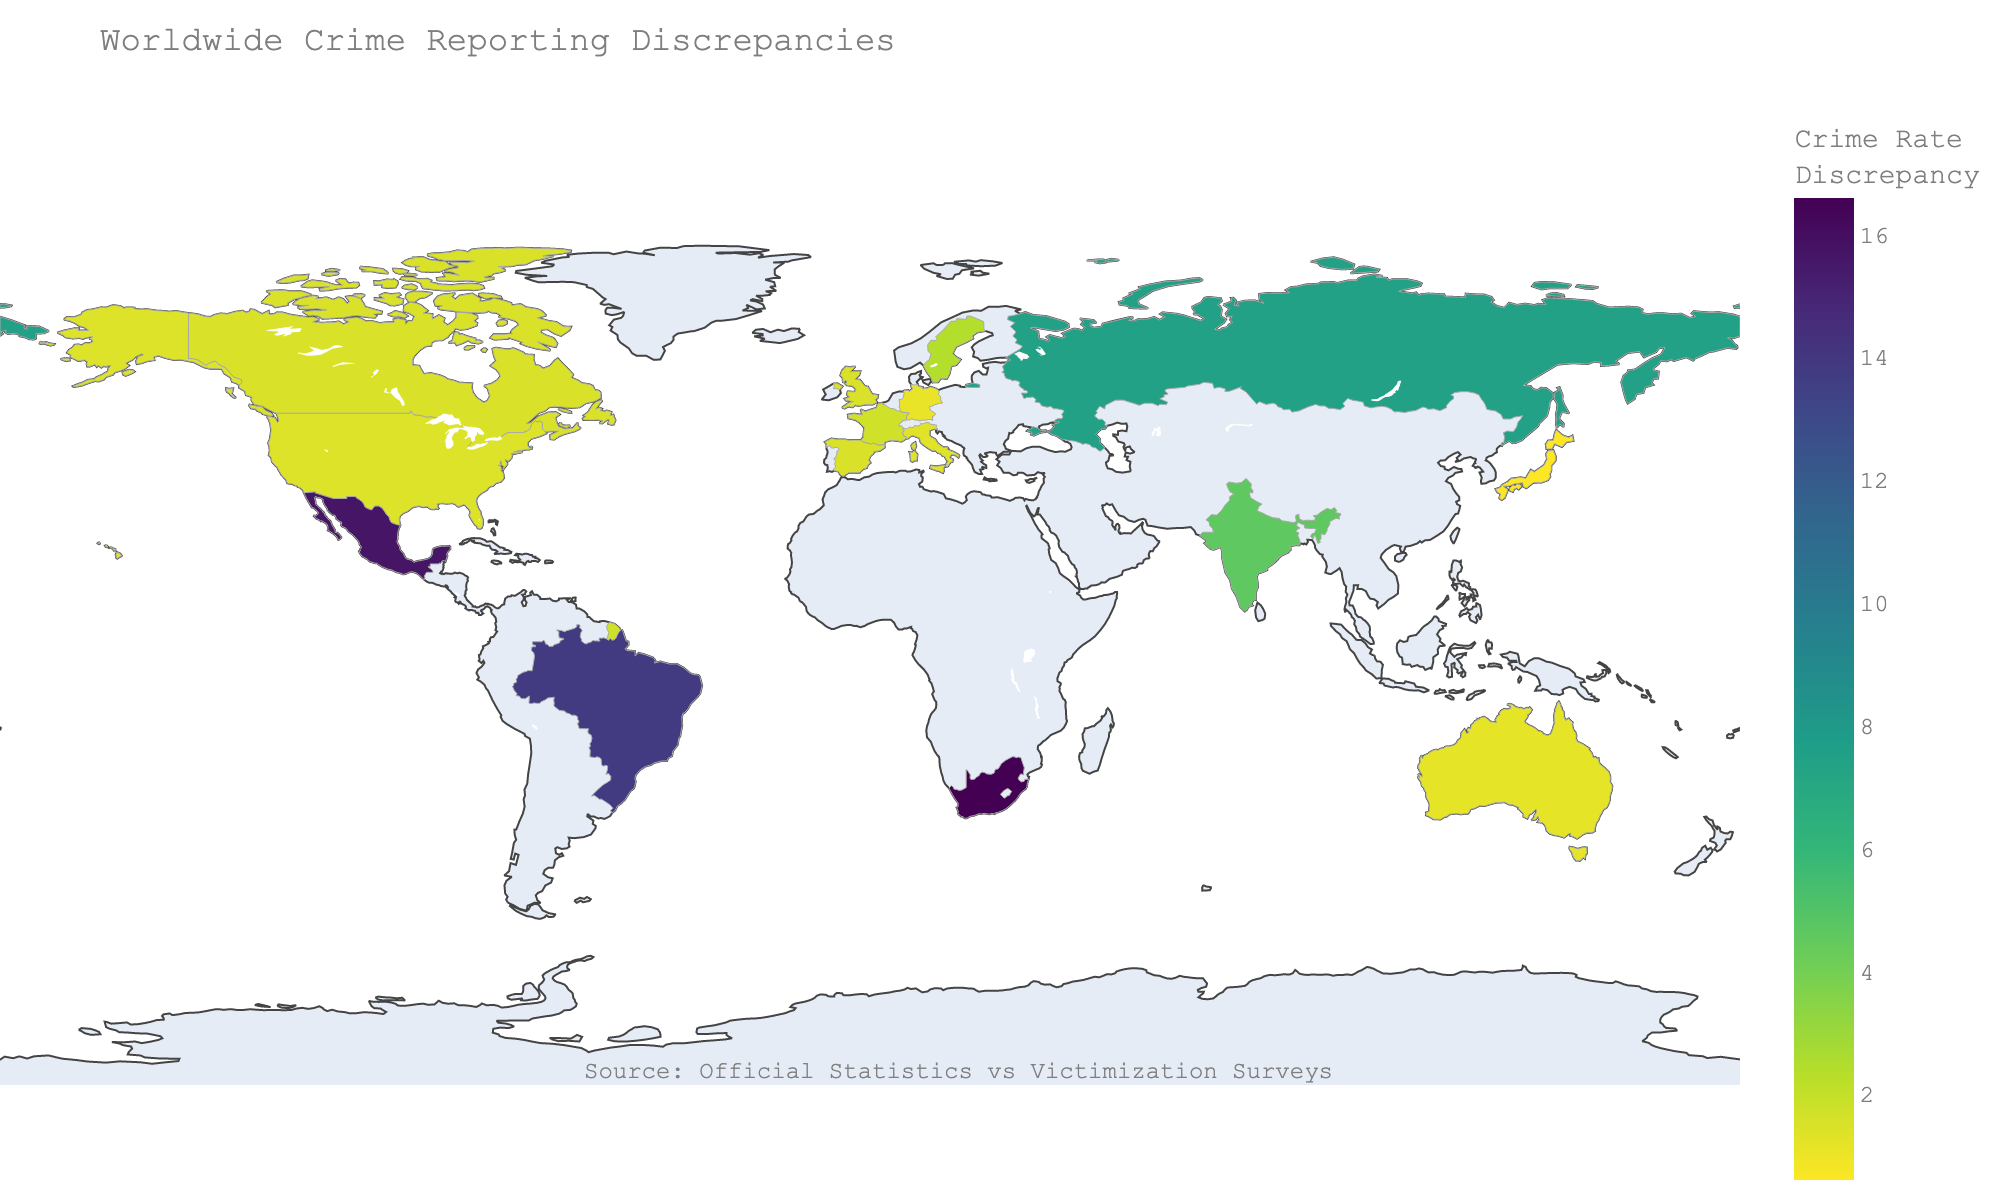What is the title of the figure? The title is usually found at the top of the figure, and it describes what the figure represents. In this case, it states "Worldwide Crime Reporting Discrepancies".
Answer: Worldwide Crime Reporting Discrepancies What is the source mentioned in the annotation of the figure? The source is mentioned in the annotation usually at the bottom or in a less prominent place of the figure. Here, it states "Source: Official Statistics vs Victimization Surveys".
Answer: Official Statistics vs Victimization Surveys Which country has the highest discrepancy in crime reporting? The figure uses color intensity to visualize discrepancies. The country with the darkest shade (most intense color) represents the highest discrepancy. Checking the intensity, South Africa has the highest discrepancy of 16.6.
Answer: South Africa What are the official and survey crime rates for Japan? The figure includes text details when a region is highlighted. For Japan, the official and survey crime rates are mentioned in the text element for Japan, being 0.3 and 0.9 respectively.
Answer: 0.3 (official), 0.9 (survey) Which countries have a crime reporting discrepancy greater than 10? By examining the intensity of color representing discrepancies, countries like Brazil, South Africa, and Mexico exhibit discrepancies greater than 10.
Answer: Brazil, South Africa, Mexico What is the average discrepancy for the listed countries? To find the average, sum up all discrepancies and divide by the number of countries. Sum = 86.8, Number of countries = 15, so average discrepancy = 86.8 / 15 = 5.79.
Answer: 5.79 Which country has the smallest discrepancy, and what is that value? The country with the lightest shade represents the smallest discrepancy. Germany shows the lightest color, indicating the smallest discrepancy of 1.1.
Answer: Germany, 1.1 Compare the discrepancies between the United States and the United Kingdom. Which is larger and by how much? The discrepancy for the United States is 1.4, and for the United Kingdom, it is 1.5. The discrepancy in the United Kingdom is larger. Difference = 1.5 - 1.4 = 0.1.
Answer: United Kingdom, 0.1 Which country shows a discrepancy close to the average value? The average discrepancy is approximately 5.79. Among the countries listed, India has a discrepancy of 4.6, which is relatively close to the average.
Answer: India 